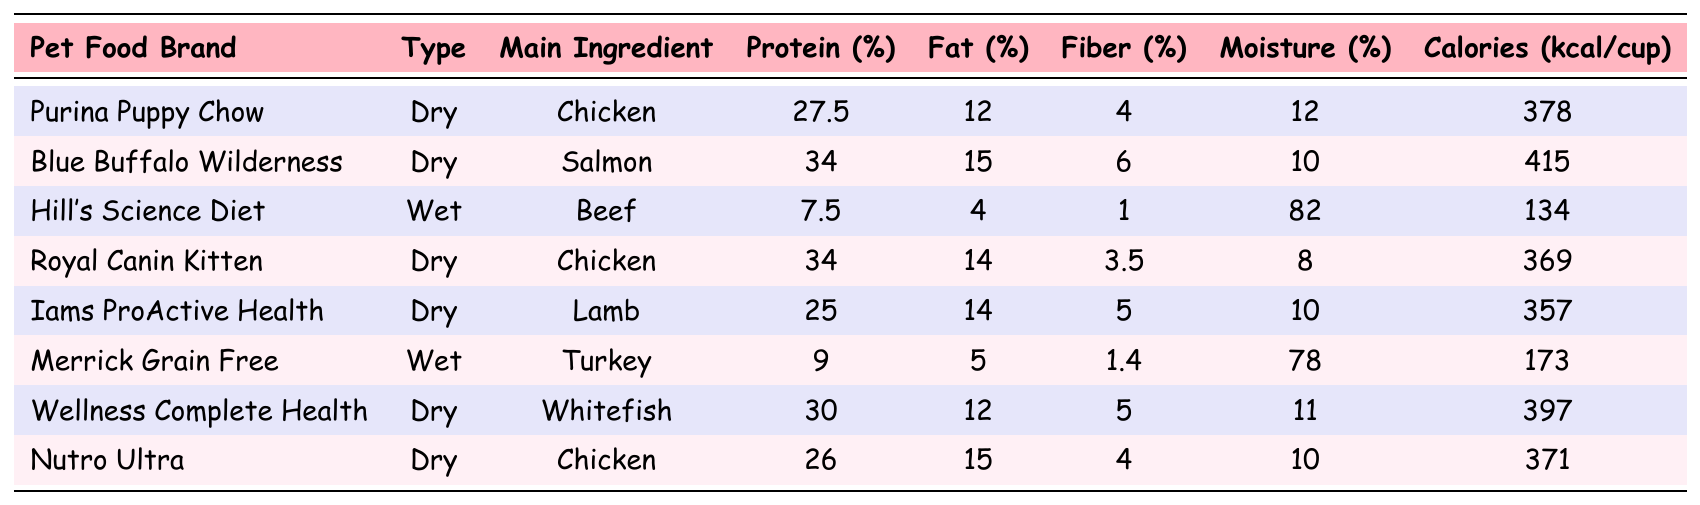What is the main ingredient in Purina Puppy Chow? The table shows that the main ingredient in Purina Puppy Chow is Chicken.
Answer: Chicken Which pet food has the highest protein percentage? Looking at the protein column, Blue Buffalo Wilderness has the highest protein percentage at 34%.
Answer: 34% How much moisture is in Hill's Science Diet? According to the table, Hill's Science Diet contains 82% moisture.
Answer: 82% What type of food is Royal Canin Kitten? The type of food for Royal Canin Kitten is Dry as indicated in the table.
Answer: Dry Is the fat percentage of Nutro Ultra greater than that of Iams ProActive Health? Nutro Ultra has a fat percentage of 15%, while Iams ProActive Health has 14%. Since 15% is greater than 14%, the answer is yes.
Answer: Yes What is the average protein percentage of all the listed dry foods? The dry foods are Purina Puppy Chow, Blue Buffalo Wilderness, Royal Canin Kitten, Iams ProActive Health, Wellness Complete Health, and Nutro Ultra. Their protein percentages are 27.5, 34, 34, 25, 30, and 26, respectively. The total is 27.5 + 34 + 34 + 25 + 30 + 26 = 176. There are 6 dry foods, so the average is 176 / 6 = 29.33.
Answer: 29.33 Which wet food has the lowest calories per cup? The wet foods are Hill's Science Diet and Merrick Grain Free. Hill's has 134 calories, and Merrick has 173 calories. Comparing these, Hill's Science Diet has the lowest calories per cup.
Answer: 134 Are there more dry foods with fat percentage above 12% than below? The dry foods with a fat percentage above 12% are Blue Buffalo Wilderness, Royal Canin Kitten, Iams ProActive Health, and Nutro Ultra, totaling 4. The only dry food with a fat percentage below 12% is Purina Puppy Chow which has 12%. Therefore, there are more dry foods above 12%.
Answer: Yes What is the difference in caloric content between Blue Buffalo Wilderness and Wellness Complete Health? Blue Buffalo Wilderness has 415 calories and Wellness Complete Health has 397 calories. The difference is 415 - 397 = 18 calories, meaning Blue Buffalo Wilderness has 18 more calories per cup.
Answer: 18 How many types of food listed are classified as wet? The table shows that there are two wet food types: Hill's Science Diet and Merrick Grain Free. Therefore, the total count is 2.
Answer: 2 Is the fiber percentage for Iams ProActive Health greater than that for Merrick Grain Free? Iams ProActive Health has a fiber percentage of 5%, while Merrick Grain Free has a fiber percentage of 1.4%. Since 5% is greater than 1.4%, the answer is yes.
Answer: Yes 